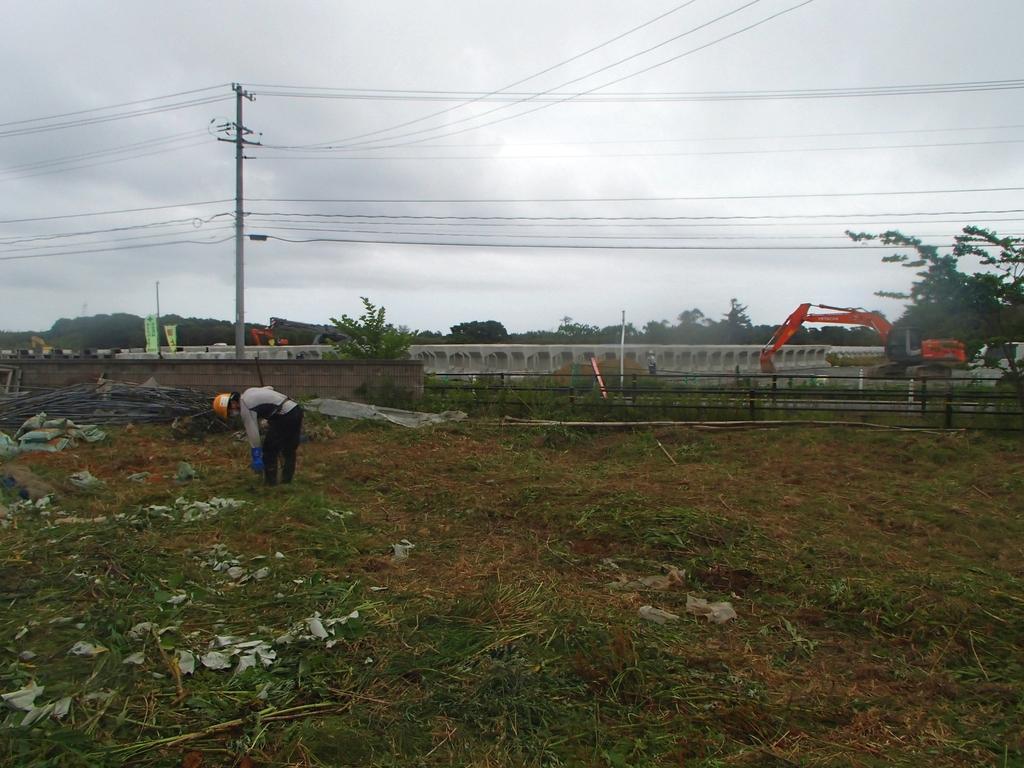Can you describe this image briefly? In this image there is the sky towards the top of the image, there are trees, there are poles, there are wires, there is a vehicle, there is a fence towards the right of the image, there is a wall towards the left of the image, there is grass, there are leaves on the ground, there are objects on the ground, there is a man, he is wearing a helmet. 